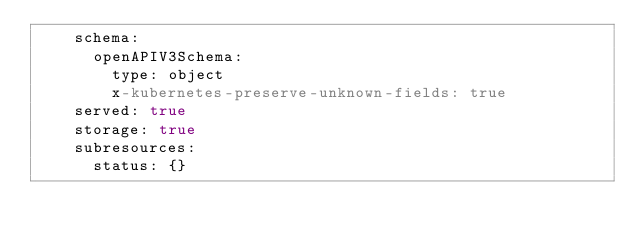<code> <loc_0><loc_0><loc_500><loc_500><_YAML_>    schema:
      openAPIV3Schema:
        type: object
        x-kubernetes-preserve-unknown-fields: true
    served: true
    storage: true
    subresources:
      status: {}
</code> 